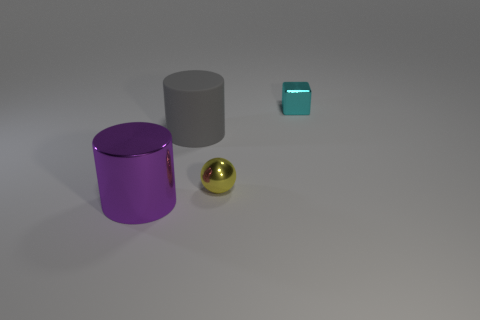Do the small metal object to the left of the tiny cyan metal block and the big object right of the large purple metal thing have the same shape? No, they do not have the same shape. The small metal object to the left of the cyan block is circular from the top and cylindrical overall, while the big object to the right of the purple cylinder appears to be spherical. 